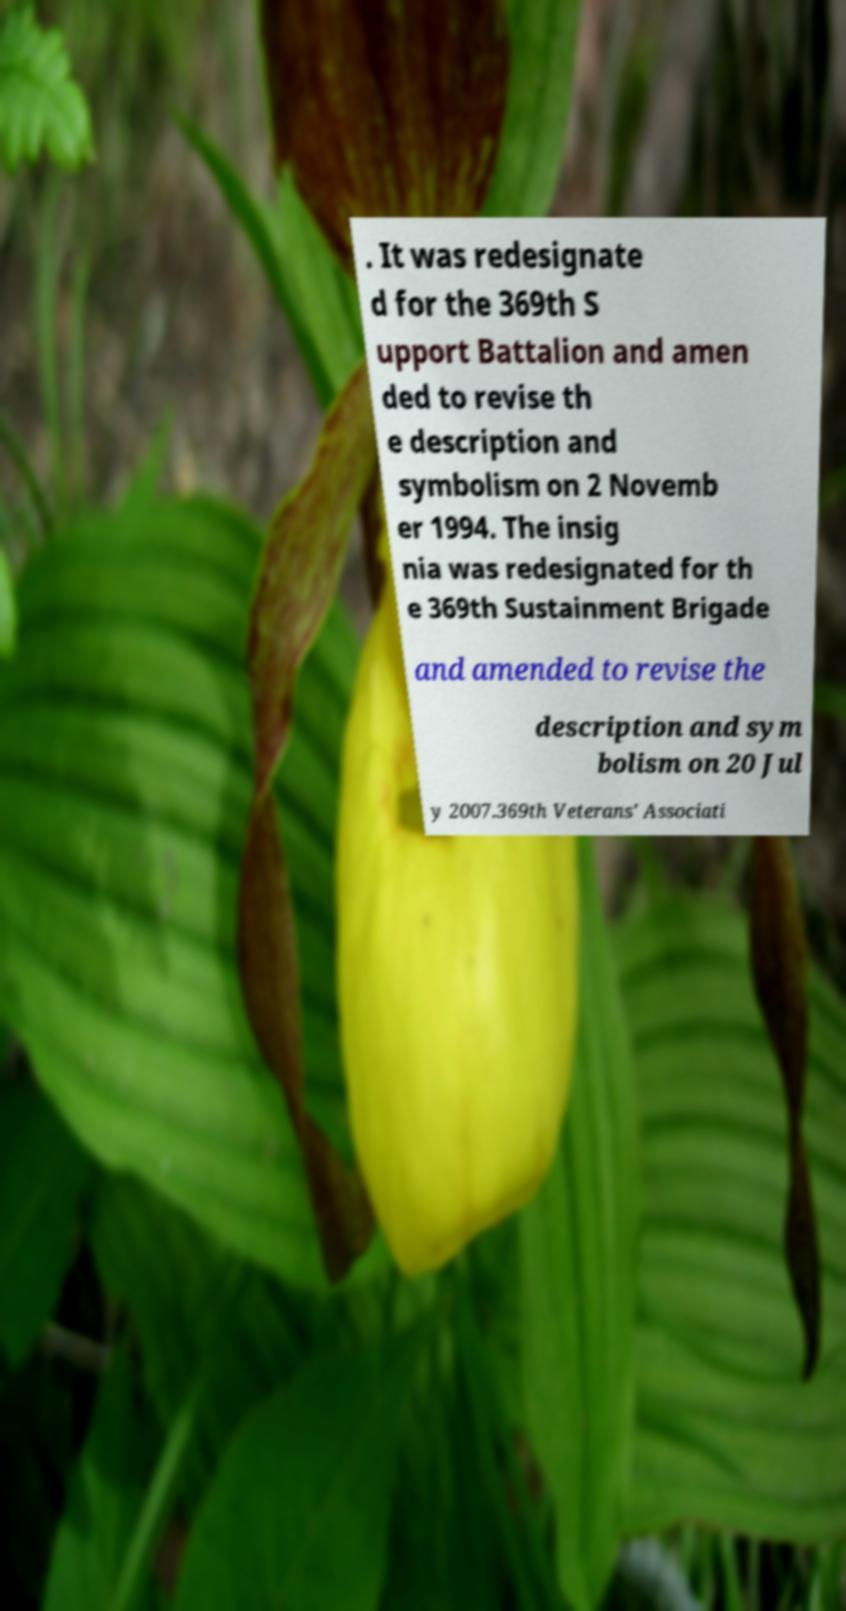I need the written content from this picture converted into text. Can you do that? . It was redesignate d for the 369th S upport Battalion and amen ded to revise th e description and symbolism on 2 Novemb er 1994. The insig nia was redesignated for th e 369th Sustainment Brigade and amended to revise the description and sym bolism on 20 Jul y 2007.369th Veterans' Associati 